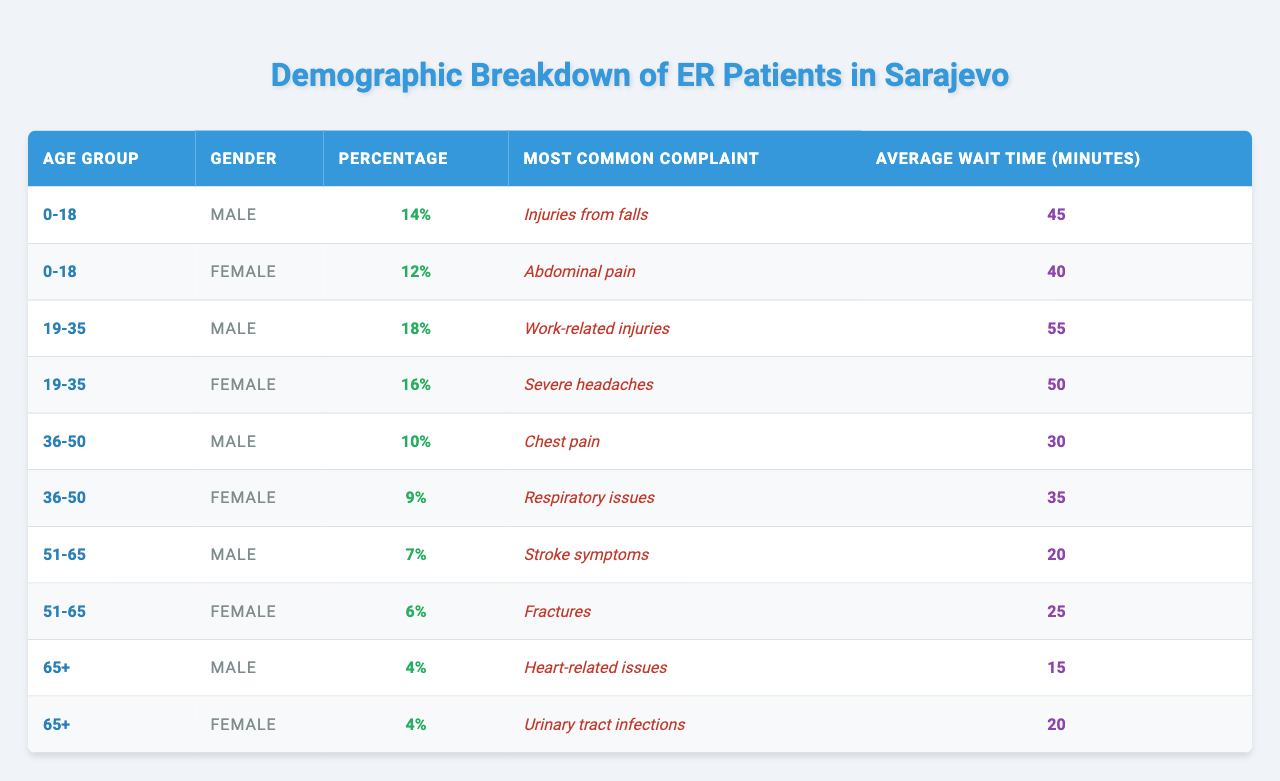What percentage of ER patients are 0-18 years old males? From the table, the percentage of males in the age group 0-18 is stated as 14%.
Answer: 14% What is the most common complaint among females aged 51-65? According to the table, the most common complaint for females aged 51-65 is "Fractures".
Answer: Fractures Which age group has the highest average wait time? The average wait time for the age group 19-35 is 55 minutes, which is the highest average wait time in the table, compared to others.
Answer: 19-35 Is the percentage of male ER patients higher than that of female patients in the age group 36-50? In the age group 36-50, the percentage of males is 10% and females is 9%, so yes, males have a higher percentage.
Answer: Yes What is the total percentage of ER patients aged 65 and older? Adding the percentages of both males and females in the age group 65+, we have 4% + 4% = 8%.
Answer: 8% What is the difference in average wait time between males and females in the age group 0-18? The average wait time for males is 45 minutes and for females is 40 minutes. The difference is 45 - 40 = 5 minutes.
Answer: 5 minutes Which gender has a higher prevalence of work-related injuries in the age group 19-35? The table indicates that 19-35 year old males have 18% reporting work-related injuries, while females have 16%. Thus, males have a higher prevalence.
Answer: Males What age group has the lowest percentage of patients in the ER? Referring to the table, the age group 65+ has the lowest percentage of patients, with both males and females at 4%.
Answer: 65+ What is the average wait time for all age groups combined? The average wait time can be calculated as: (45 + 40 + 55 + 50 + 30 + 35 + 20 + 25 + 15 + 20) / 10 = 39.5 minutes.
Answer: 39.5 minutes Is it true that the most common complaint for males aged 51-65 is "Heart-related issues"? The table clearly indicates that the most common complaint for this age group (51-65 males) is "Stroke symptoms", making the statement false.
Answer: No 